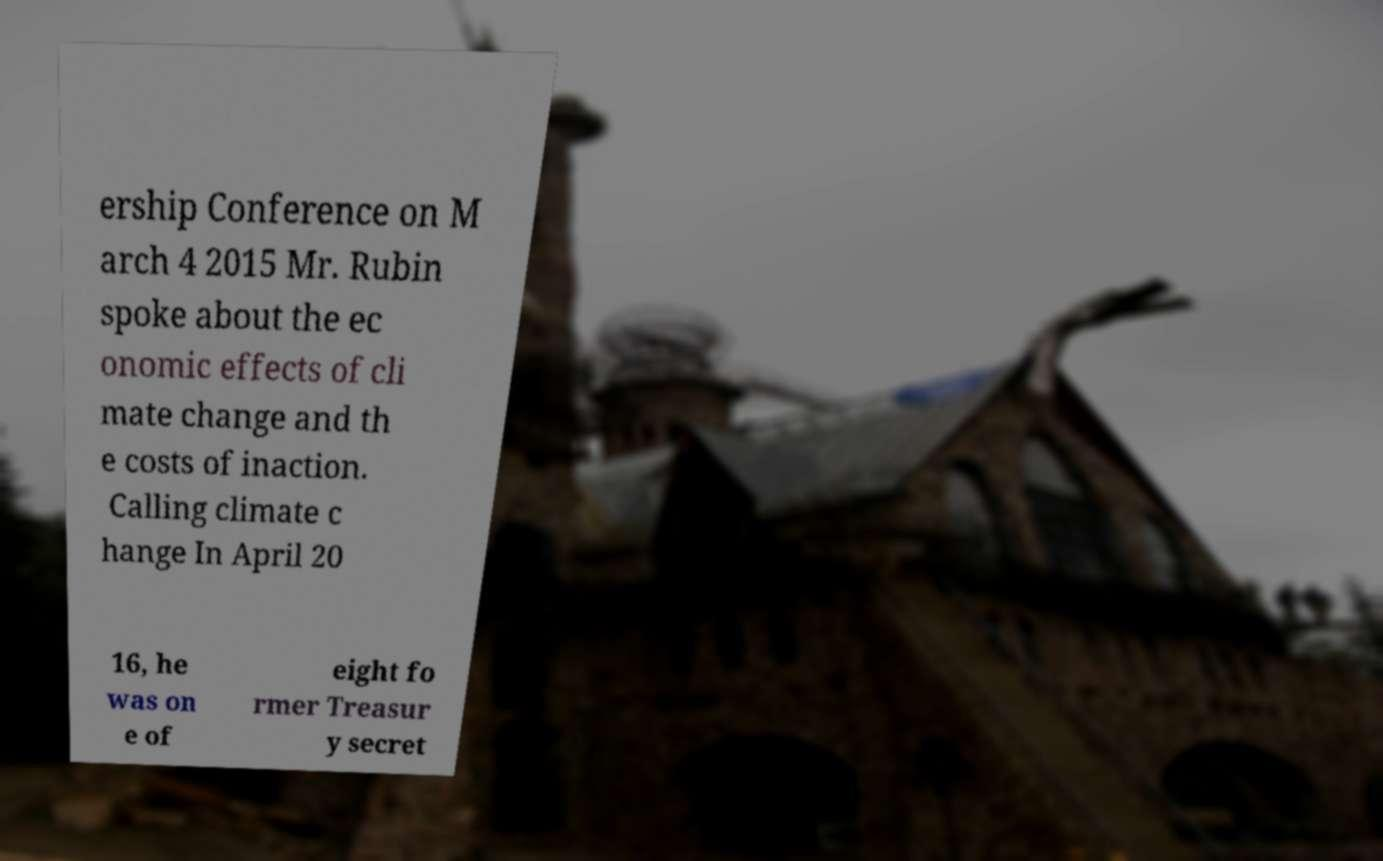What messages or text are displayed in this image? I need them in a readable, typed format. ership Conference on M arch 4 2015 Mr. Rubin spoke about the ec onomic effects of cli mate change and th e costs of inaction. Calling climate c hange In April 20 16, he was on e of eight fo rmer Treasur y secret 